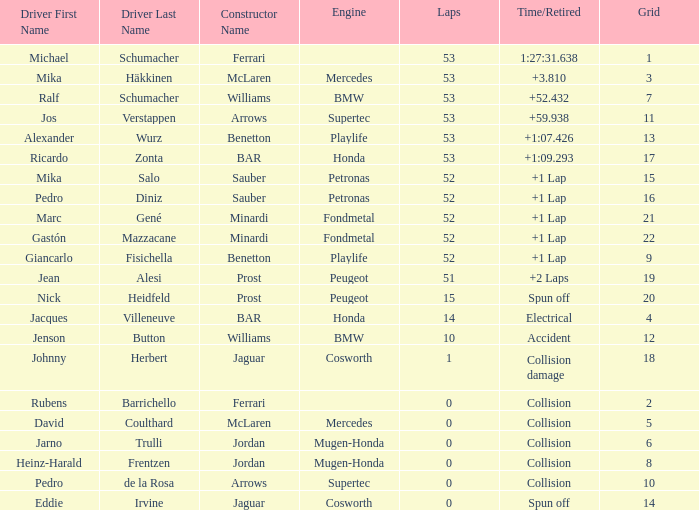What is the count of laps ricardo zonta had? 53.0. 